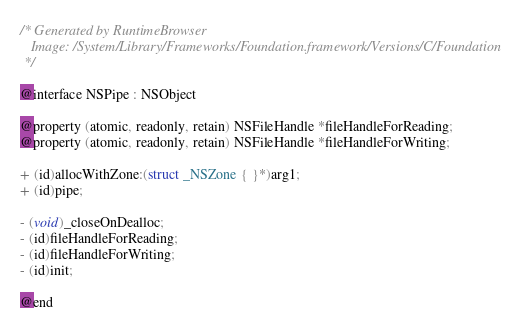<code> <loc_0><loc_0><loc_500><loc_500><_C_>/* Generated by RuntimeBrowser
   Image: /System/Library/Frameworks/Foundation.framework/Versions/C/Foundation
 */

@interface NSPipe : NSObject

@property (atomic, readonly, retain) NSFileHandle *fileHandleForReading;
@property (atomic, readonly, retain) NSFileHandle *fileHandleForWriting;

+ (id)allocWithZone:(struct _NSZone { }*)arg1;
+ (id)pipe;

- (void)_closeOnDealloc;
- (id)fileHandleForReading;
- (id)fileHandleForWriting;
- (id)init;

@end
</code> 